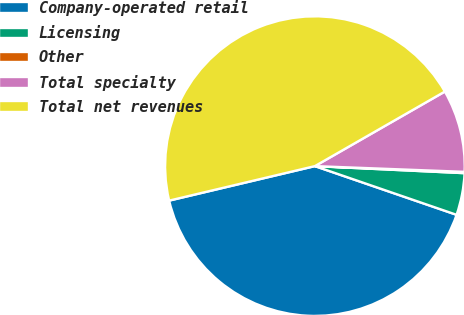<chart> <loc_0><loc_0><loc_500><loc_500><pie_chart><fcel>Company-operated retail<fcel>Licensing<fcel>Other<fcel>Total specialty<fcel>Total net revenues<nl><fcel>41.03%<fcel>4.52%<fcel>0.14%<fcel>8.9%<fcel>45.41%<nl></chart> 